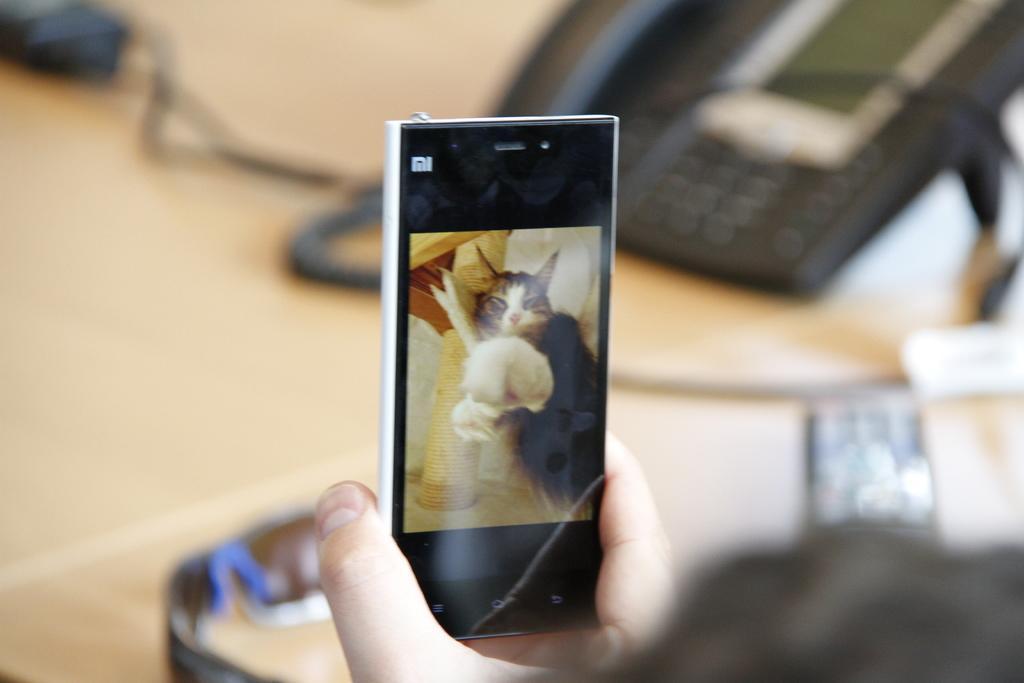Could you give a brief overview of what you see in this image? At the bottom of the image there is a hand of a person with a mobile. On the mobile screen, there is a cat and some other things. Behind the mobile, there is a table with a telephone, goggles and some other things. 